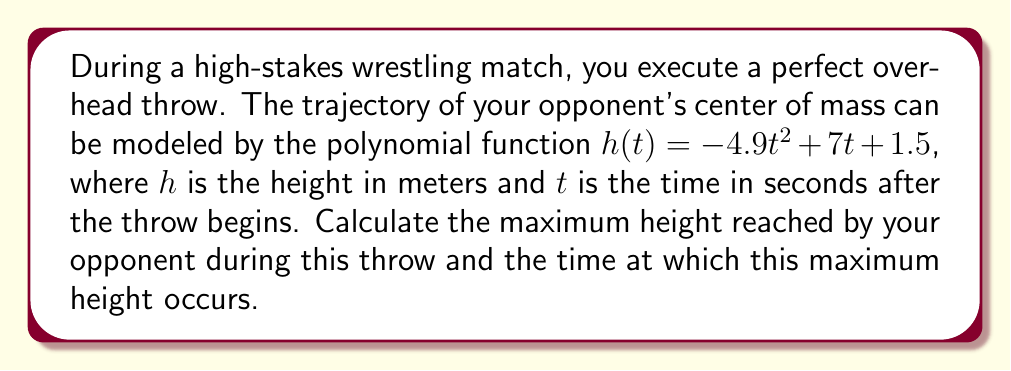Could you help me with this problem? To solve this problem, we'll follow these steps:

1) The trajectory is modeled by a quadratic function: $h(t) = -4.9t^2 + 7t + 1.5$

2) To find the maximum height, we need to find the vertex of this parabola. For a quadratic function in the form $f(x) = ax^2 + bx + c$, the x-coordinate of the vertex is given by $x = -\frac{b}{2a}$

3) In our case, $a = -4.9$, $b = 7$, and $c = 1.5$

4) Let's calculate the time at which the maximum height occurs:

   $t = -\frac{b}{2a} = -\frac{7}{2(-4.9)} = \frac{7}{9.8} \approx 0.714$ seconds

5) To find the maximum height, we substitute this t-value back into our original function:

   $h(0.714) = -4.9(0.714)^2 + 7(0.714) + 1.5$
              $= -4.9(0.510) + 5.000 + 1.5$
              $= -2.499 + 5.000 + 1.5$
              $= 4.001$ meters

6) We can round this to 4.0 meters for a more practical answer.
Answer: The maximum height reached is approximately 4.0 meters, occurring at about 0.714 seconds after the throw begins. 